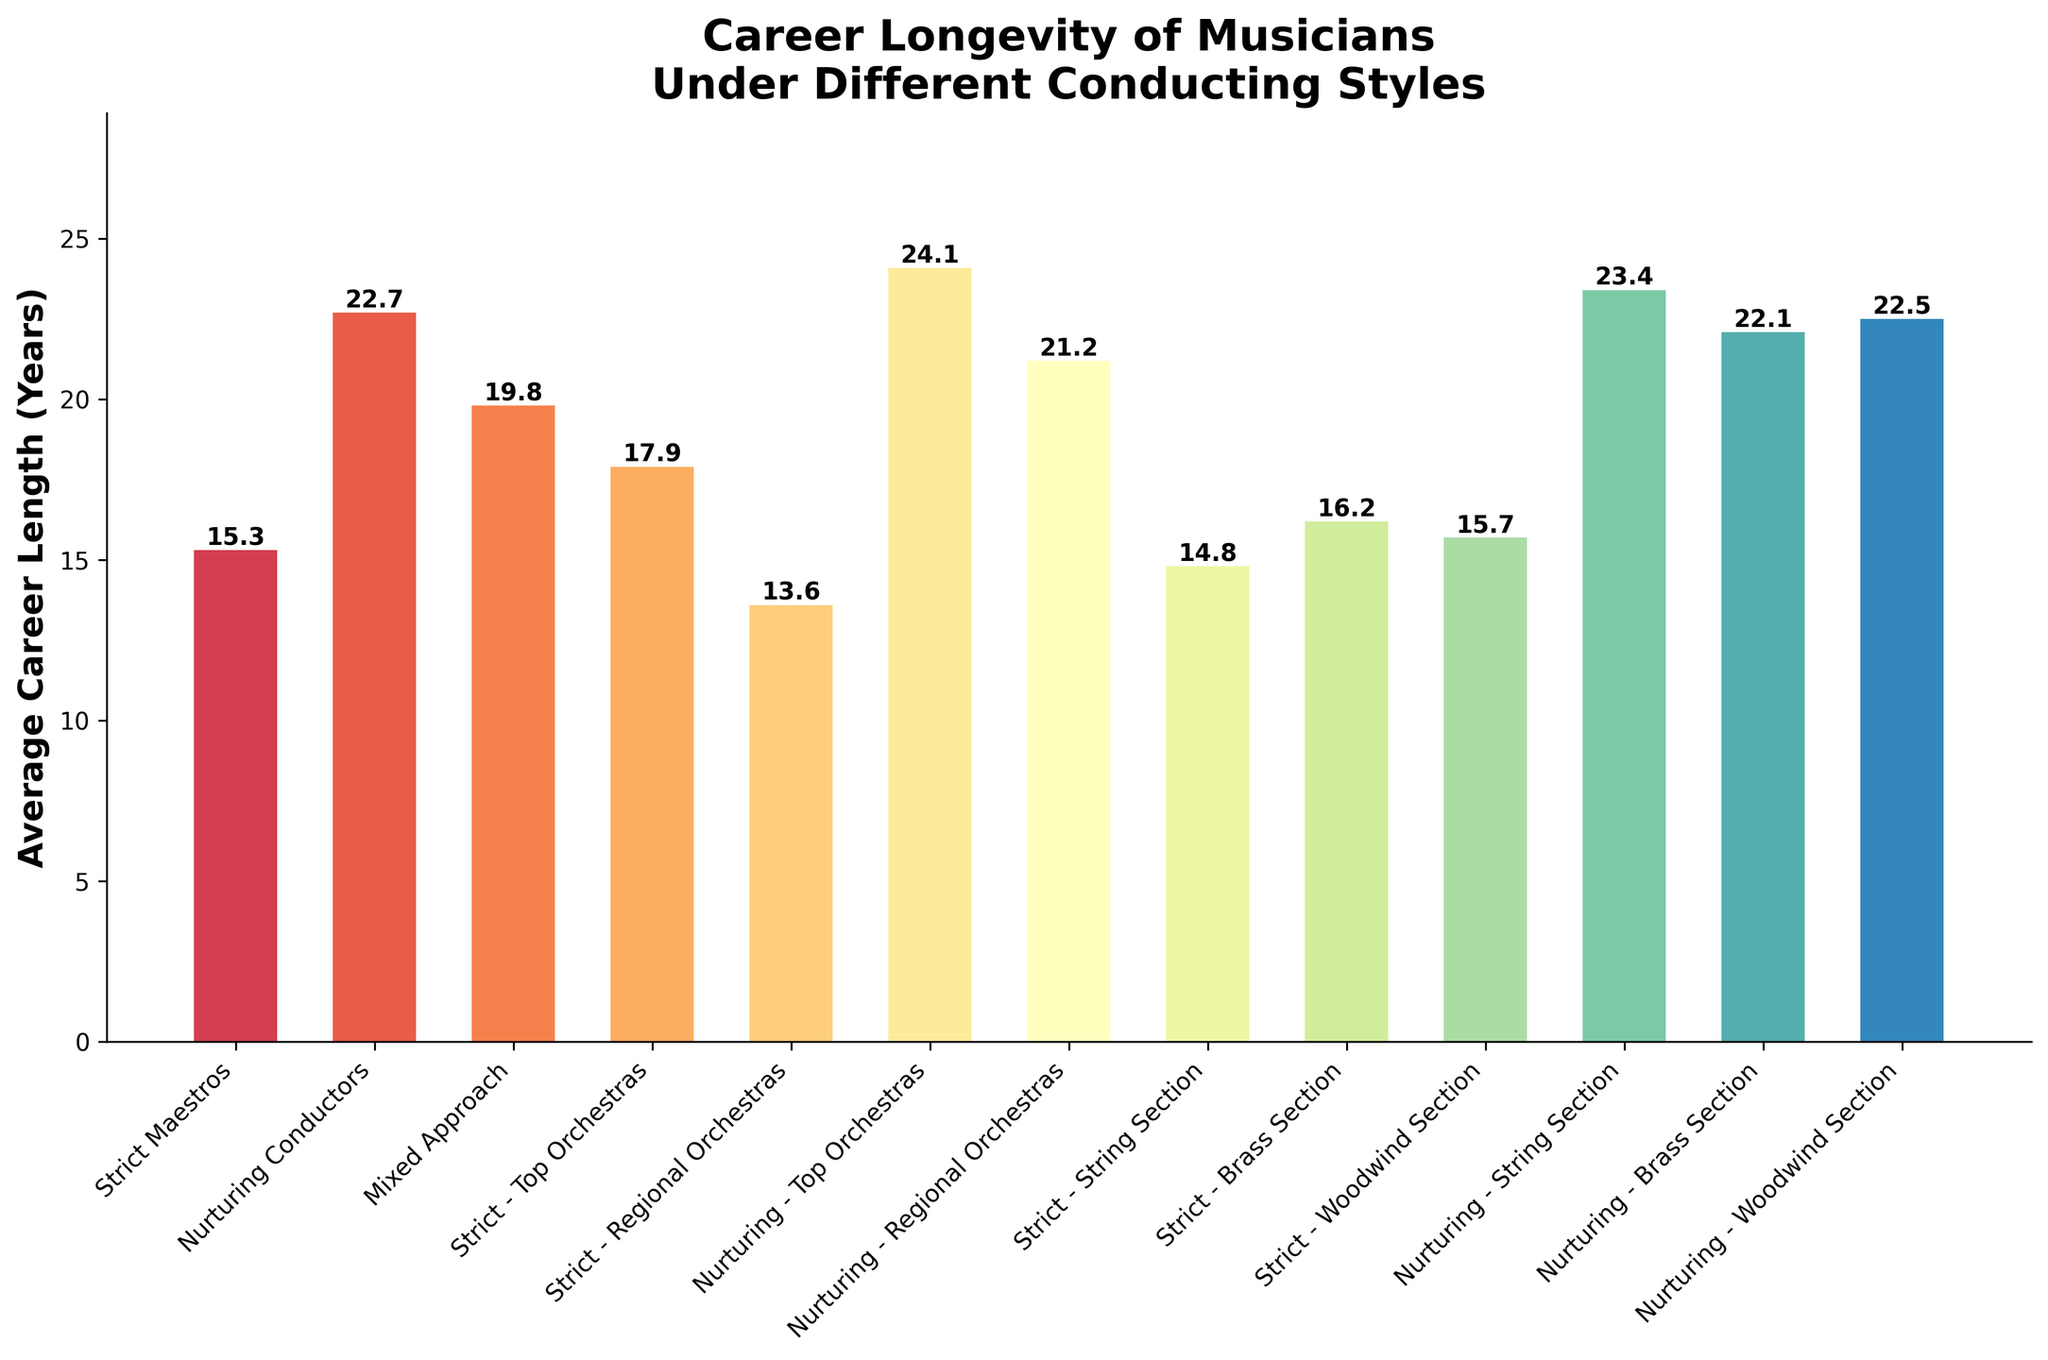What is the average career length of musicians trained by nurturing conductors in top orchestras compared to those in regional orchestras? Nurturing - Top Orchestras have an average career length of 24.1 years, while Nurturing - Regional Orchestras have an average career length of 21.2 years. The comparison shows that musicians in top orchestras have a higher average career length.
Answer: 24.1 years vs 21.2 years Which conductor type has the shortest average career length? The shortest bar in the chart represents "Strict - Regional Orchestras," indicating the lowest average career length of 13.6 years among all categories.
Answer: Strict - Regional Orchestras (13.6 years) How much longer is the average career length under nurturing conductors compared to strict maestros? The average career length under Nurturing Conductors is 22.7 years and under Strict Maestros is 15.3 years. The difference is 22.7 - 15.3 = 7.4 years.
Answer: 7.4 years What is the difference in average career length between musicians trained under a mixed approach and those under strict maestros in top orchestras? Mixed Approach has an average career length of 19.8 years, and Strict - Top Orchestras have an average career length of 17.9 years. The difference is 19.8 - 17.9 = 1.9 years.
Answer: 1.9 years Which section has the longest average career under nurturing conductors? The tallest bars within nurturing conductor categories are Nurturing - String Section (23.4 years), Nurturing - Brass Section (22.1 years), and Nurturing - Woodwind Section (22.5 years). The longest average career is for the String Section.
Answer: String Section (23.4 years) What is the average career length of musicians under strict conductors in the string section compared to brass and woodwind sections? Strict - String Section has an average career length of 14.8 years, Strict - Brass Section has 16.2 years, and Strict - Woodwind Section has 15.7 years. String Section has the shortest average career length compared to Brass and Woodwind Sections.
Answer: 14.8 years vs 16.2 years and 15.7 years How do the career lengths of musicians vary between top and regional orchestras under strict maestros? Strict - Top Orchestras have an average career length of 17.9 years, while Strict - Regional Orchestras have an average career length of 13.6 years. The average career length is longer in top orchestras by 17.9 - 13.6 = 4.3 years.
Answer: 4.3 years What is the average career length difference between the nurturing string section and strict string section? Nurturing - String Section has an average career length of 23.4 years, and Strict - String Section has 14.8 years. The difference is 23.4 - 14.8 = 8.6 years.
Answer: 8.6 years Across all categories, which group shows the highest average career length? The bar representing "Nurturing - Top Orchestras" is the highest among all, showing an average career length of 24.1 years.
Answer: Nurturing - Top Orchestras (24.1 years) 